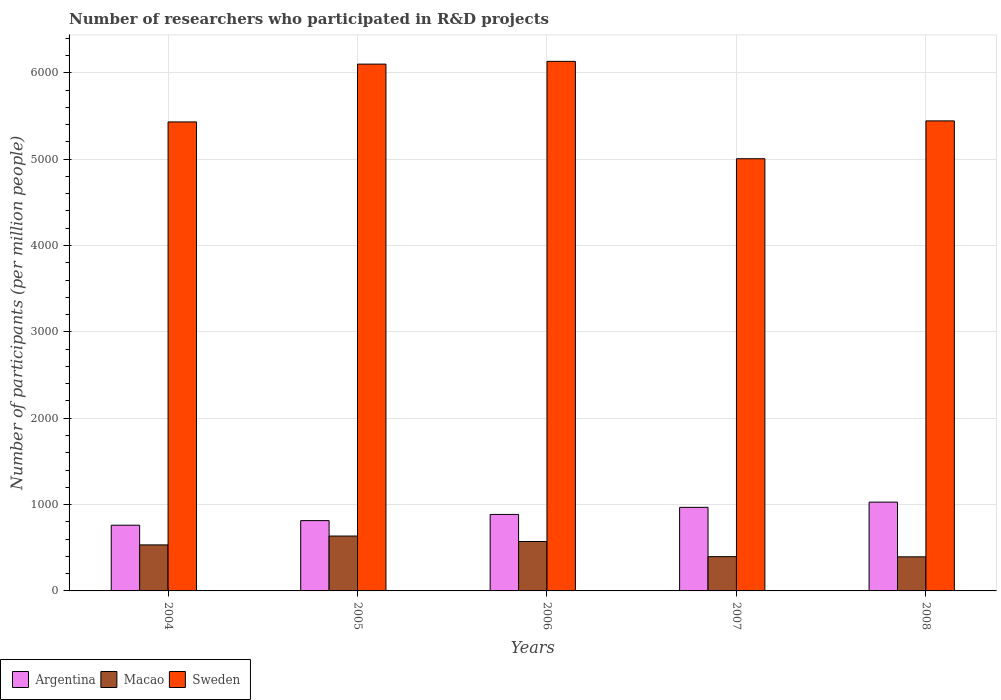How many different coloured bars are there?
Provide a short and direct response. 3. How many groups of bars are there?
Offer a terse response. 5. Are the number of bars per tick equal to the number of legend labels?
Your answer should be compact. Yes. How many bars are there on the 2nd tick from the left?
Provide a succinct answer. 3. How many bars are there on the 3rd tick from the right?
Provide a succinct answer. 3. What is the label of the 1st group of bars from the left?
Keep it short and to the point. 2004. What is the number of researchers who participated in R&D projects in Macao in 2005?
Your response must be concise. 635.48. Across all years, what is the maximum number of researchers who participated in R&D projects in Argentina?
Provide a succinct answer. 1028.26. Across all years, what is the minimum number of researchers who participated in R&D projects in Argentina?
Give a very brief answer. 760.96. In which year was the number of researchers who participated in R&D projects in Sweden maximum?
Ensure brevity in your answer.  2006. What is the total number of researchers who participated in R&D projects in Macao in the graph?
Your answer should be compact. 2532.44. What is the difference between the number of researchers who participated in R&D projects in Argentina in 2004 and that in 2007?
Offer a terse response. -206.79. What is the difference between the number of researchers who participated in R&D projects in Argentina in 2008 and the number of researchers who participated in R&D projects in Macao in 2006?
Your answer should be very brief. 455.85. What is the average number of researchers who participated in R&D projects in Sweden per year?
Your response must be concise. 5622.51. In the year 2005, what is the difference between the number of researchers who participated in R&D projects in Macao and number of researchers who participated in R&D projects in Argentina?
Keep it short and to the point. -178.61. What is the ratio of the number of researchers who participated in R&D projects in Macao in 2004 to that in 2006?
Your response must be concise. 0.93. Is the number of researchers who participated in R&D projects in Macao in 2005 less than that in 2008?
Your answer should be very brief. No. Is the difference between the number of researchers who participated in R&D projects in Macao in 2006 and 2007 greater than the difference between the number of researchers who participated in R&D projects in Argentina in 2006 and 2007?
Offer a very short reply. Yes. What is the difference between the highest and the second highest number of researchers who participated in R&D projects in Argentina?
Your answer should be very brief. 60.51. What is the difference between the highest and the lowest number of researchers who participated in R&D projects in Argentina?
Your response must be concise. 267.3. In how many years, is the number of researchers who participated in R&D projects in Argentina greater than the average number of researchers who participated in R&D projects in Argentina taken over all years?
Your answer should be very brief. 2. Is the sum of the number of researchers who participated in R&D projects in Argentina in 2004 and 2006 greater than the maximum number of researchers who participated in R&D projects in Sweden across all years?
Your answer should be compact. No. What does the 1st bar from the left in 2007 represents?
Offer a terse response. Argentina. What does the 1st bar from the right in 2006 represents?
Offer a terse response. Sweden. How many years are there in the graph?
Your response must be concise. 5. What is the difference between two consecutive major ticks on the Y-axis?
Provide a succinct answer. 1000. Are the values on the major ticks of Y-axis written in scientific E-notation?
Your response must be concise. No. Does the graph contain any zero values?
Provide a succinct answer. No. Does the graph contain grids?
Provide a short and direct response. Yes. How many legend labels are there?
Provide a succinct answer. 3. How are the legend labels stacked?
Give a very brief answer. Horizontal. What is the title of the graph?
Your response must be concise. Number of researchers who participated in R&D projects. What is the label or title of the Y-axis?
Offer a very short reply. Number of participants (per million people). What is the Number of participants (per million people) in Argentina in 2004?
Provide a succinct answer. 760.96. What is the Number of participants (per million people) of Macao in 2004?
Offer a terse response. 532.95. What is the Number of participants (per million people) of Sweden in 2004?
Keep it short and to the point. 5431.14. What is the Number of participants (per million people) in Argentina in 2005?
Keep it short and to the point. 814.09. What is the Number of participants (per million people) in Macao in 2005?
Your answer should be compact. 635.48. What is the Number of participants (per million people) in Sweden in 2005?
Offer a very short reply. 6100.67. What is the Number of participants (per million people) in Argentina in 2006?
Offer a terse response. 885.77. What is the Number of participants (per million people) in Macao in 2006?
Your answer should be very brief. 572.41. What is the Number of participants (per million people) of Sweden in 2006?
Give a very brief answer. 6132.66. What is the Number of participants (per million people) in Argentina in 2007?
Offer a very short reply. 967.75. What is the Number of participants (per million people) in Macao in 2007?
Your answer should be compact. 396.94. What is the Number of participants (per million people) of Sweden in 2007?
Your answer should be compact. 5004.96. What is the Number of participants (per million people) of Argentina in 2008?
Ensure brevity in your answer.  1028.26. What is the Number of participants (per million people) in Macao in 2008?
Offer a very short reply. 394.66. What is the Number of participants (per million people) of Sweden in 2008?
Give a very brief answer. 5443.12. Across all years, what is the maximum Number of participants (per million people) in Argentina?
Offer a very short reply. 1028.26. Across all years, what is the maximum Number of participants (per million people) of Macao?
Provide a short and direct response. 635.48. Across all years, what is the maximum Number of participants (per million people) in Sweden?
Your answer should be compact. 6132.66. Across all years, what is the minimum Number of participants (per million people) of Argentina?
Provide a short and direct response. 760.96. Across all years, what is the minimum Number of participants (per million people) of Macao?
Offer a terse response. 394.66. Across all years, what is the minimum Number of participants (per million people) of Sweden?
Give a very brief answer. 5004.96. What is the total Number of participants (per million people) of Argentina in the graph?
Give a very brief answer. 4456.83. What is the total Number of participants (per million people) of Macao in the graph?
Your answer should be compact. 2532.44. What is the total Number of participants (per million people) of Sweden in the graph?
Give a very brief answer. 2.81e+04. What is the difference between the Number of participants (per million people) of Argentina in 2004 and that in 2005?
Provide a succinct answer. -53.13. What is the difference between the Number of participants (per million people) of Macao in 2004 and that in 2005?
Ensure brevity in your answer.  -102.53. What is the difference between the Number of participants (per million people) of Sweden in 2004 and that in 2005?
Your response must be concise. -669.53. What is the difference between the Number of participants (per million people) in Argentina in 2004 and that in 2006?
Ensure brevity in your answer.  -124.81. What is the difference between the Number of participants (per million people) of Macao in 2004 and that in 2006?
Provide a short and direct response. -39.46. What is the difference between the Number of participants (per million people) in Sweden in 2004 and that in 2006?
Provide a short and direct response. -701.52. What is the difference between the Number of participants (per million people) of Argentina in 2004 and that in 2007?
Offer a very short reply. -206.79. What is the difference between the Number of participants (per million people) in Macao in 2004 and that in 2007?
Give a very brief answer. 136.01. What is the difference between the Number of participants (per million people) of Sweden in 2004 and that in 2007?
Give a very brief answer. 426.17. What is the difference between the Number of participants (per million people) of Argentina in 2004 and that in 2008?
Offer a terse response. -267.3. What is the difference between the Number of participants (per million people) of Macao in 2004 and that in 2008?
Keep it short and to the point. 138.29. What is the difference between the Number of participants (per million people) in Sweden in 2004 and that in 2008?
Ensure brevity in your answer.  -11.98. What is the difference between the Number of participants (per million people) in Argentina in 2005 and that in 2006?
Ensure brevity in your answer.  -71.68. What is the difference between the Number of participants (per million people) in Macao in 2005 and that in 2006?
Make the answer very short. 63.07. What is the difference between the Number of participants (per million people) of Sweden in 2005 and that in 2006?
Give a very brief answer. -31.99. What is the difference between the Number of participants (per million people) of Argentina in 2005 and that in 2007?
Provide a short and direct response. -153.66. What is the difference between the Number of participants (per million people) of Macao in 2005 and that in 2007?
Give a very brief answer. 238.54. What is the difference between the Number of participants (per million people) of Sweden in 2005 and that in 2007?
Provide a short and direct response. 1095.7. What is the difference between the Number of participants (per million people) of Argentina in 2005 and that in 2008?
Offer a very short reply. -214.17. What is the difference between the Number of participants (per million people) of Macao in 2005 and that in 2008?
Your answer should be compact. 240.82. What is the difference between the Number of participants (per million people) of Sweden in 2005 and that in 2008?
Provide a succinct answer. 657.55. What is the difference between the Number of participants (per million people) of Argentina in 2006 and that in 2007?
Ensure brevity in your answer.  -81.98. What is the difference between the Number of participants (per million people) of Macao in 2006 and that in 2007?
Ensure brevity in your answer.  175.47. What is the difference between the Number of participants (per million people) in Sweden in 2006 and that in 2007?
Keep it short and to the point. 1127.7. What is the difference between the Number of participants (per million people) of Argentina in 2006 and that in 2008?
Keep it short and to the point. -142.49. What is the difference between the Number of participants (per million people) in Macao in 2006 and that in 2008?
Your answer should be very brief. 177.75. What is the difference between the Number of participants (per million people) of Sweden in 2006 and that in 2008?
Provide a succinct answer. 689.54. What is the difference between the Number of participants (per million people) of Argentina in 2007 and that in 2008?
Your response must be concise. -60.51. What is the difference between the Number of participants (per million people) of Macao in 2007 and that in 2008?
Your answer should be compact. 2.28. What is the difference between the Number of participants (per million people) in Sweden in 2007 and that in 2008?
Give a very brief answer. -438.15. What is the difference between the Number of participants (per million people) in Argentina in 2004 and the Number of participants (per million people) in Macao in 2005?
Ensure brevity in your answer.  125.48. What is the difference between the Number of participants (per million people) in Argentina in 2004 and the Number of participants (per million people) in Sweden in 2005?
Your answer should be very brief. -5339.71. What is the difference between the Number of participants (per million people) in Macao in 2004 and the Number of participants (per million people) in Sweden in 2005?
Provide a succinct answer. -5567.71. What is the difference between the Number of participants (per million people) of Argentina in 2004 and the Number of participants (per million people) of Macao in 2006?
Give a very brief answer. 188.55. What is the difference between the Number of participants (per million people) of Argentina in 2004 and the Number of participants (per million people) of Sweden in 2006?
Your response must be concise. -5371.7. What is the difference between the Number of participants (per million people) in Macao in 2004 and the Number of participants (per million people) in Sweden in 2006?
Keep it short and to the point. -5599.71. What is the difference between the Number of participants (per million people) in Argentina in 2004 and the Number of participants (per million people) in Macao in 2007?
Offer a terse response. 364.02. What is the difference between the Number of participants (per million people) in Argentina in 2004 and the Number of participants (per million people) in Sweden in 2007?
Your answer should be compact. -4244. What is the difference between the Number of participants (per million people) of Macao in 2004 and the Number of participants (per million people) of Sweden in 2007?
Offer a very short reply. -4472.01. What is the difference between the Number of participants (per million people) in Argentina in 2004 and the Number of participants (per million people) in Macao in 2008?
Your answer should be compact. 366.3. What is the difference between the Number of participants (per million people) of Argentina in 2004 and the Number of participants (per million people) of Sweden in 2008?
Provide a succinct answer. -4682.16. What is the difference between the Number of participants (per million people) in Macao in 2004 and the Number of participants (per million people) in Sweden in 2008?
Offer a terse response. -4910.17. What is the difference between the Number of participants (per million people) of Argentina in 2005 and the Number of participants (per million people) of Macao in 2006?
Offer a terse response. 241.68. What is the difference between the Number of participants (per million people) of Argentina in 2005 and the Number of participants (per million people) of Sweden in 2006?
Offer a very short reply. -5318.57. What is the difference between the Number of participants (per million people) in Macao in 2005 and the Number of participants (per million people) in Sweden in 2006?
Your answer should be compact. -5497.18. What is the difference between the Number of participants (per million people) in Argentina in 2005 and the Number of participants (per million people) in Macao in 2007?
Your answer should be compact. 417.15. What is the difference between the Number of participants (per million people) in Argentina in 2005 and the Number of participants (per million people) in Sweden in 2007?
Ensure brevity in your answer.  -4190.87. What is the difference between the Number of participants (per million people) of Macao in 2005 and the Number of participants (per million people) of Sweden in 2007?
Your response must be concise. -4369.48. What is the difference between the Number of participants (per million people) in Argentina in 2005 and the Number of participants (per million people) in Macao in 2008?
Offer a very short reply. 419.43. What is the difference between the Number of participants (per million people) of Argentina in 2005 and the Number of participants (per million people) of Sweden in 2008?
Your answer should be compact. -4629.02. What is the difference between the Number of participants (per million people) in Macao in 2005 and the Number of participants (per million people) in Sweden in 2008?
Keep it short and to the point. -4807.63. What is the difference between the Number of participants (per million people) in Argentina in 2006 and the Number of participants (per million people) in Macao in 2007?
Your answer should be very brief. 488.83. What is the difference between the Number of participants (per million people) of Argentina in 2006 and the Number of participants (per million people) of Sweden in 2007?
Your response must be concise. -4119.19. What is the difference between the Number of participants (per million people) of Macao in 2006 and the Number of participants (per million people) of Sweden in 2007?
Provide a succinct answer. -4432.55. What is the difference between the Number of participants (per million people) of Argentina in 2006 and the Number of participants (per million people) of Macao in 2008?
Your answer should be compact. 491.11. What is the difference between the Number of participants (per million people) in Argentina in 2006 and the Number of participants (per million people) in Sweden in 2008?
Keep it short and to the point. -4557.34. What is the difference between the Number of participants (per million people) in Macao in 2006 and the Number of participants (per million people) in Sweden in 2008?
Give a very brief answer. -4870.71. What is the difference between the Number of participants (per million people) of Argentina in 2007 and the Number of participants (per million people) of Macao in 2008?
Your answer should be compact. 573.09. What is the difference between the Number of participants (per million people) in Argentina in 2007 and the Number of participants (per million people) in Sweden in 2008?
Give a very brief answer. -4475.36. What is the difference between the Number of participants (per million people) in Macao in 2007 and the Number of participants (per million people) in Sweden in 2008?
Ensure brevity in your answer.  -5046.18. What is the average Number of participants (per million people) of Argentina per year?
Your response must be concise. 891.37. What is the average Number of participants (per million people) of Macao per year?
Offer a terse response. 506.49. What is the average Number of participants (per million people) of Sweden per year?
Your response must be concise. 5622.51. In the year 2004, what is the difference between the Number of participants (per million people) of Argentina and Number of participants (per million people) of Macao?
Ensure brevity in your answer.  228.01. In the year 2004, what is the difference between the Number of participants (per million people) in Argentina and Number of participants (per million people) in Sweden?
Make the answer very short. -4670.18. In the year 2004, what is the difference between the Number of participants (per million people) of Macao and Number of participants (per million people) of Sweden?
Your answer should be compact. -4898.19. In the year 2005, what is the difference between the Number of participants (per million people) of Argentina and Number of participants (per million people) of Macao?
Your answer should be compact. 178.61. In the year 2005, what is the difference between the Number of participants (per million people) in Argentina and Number of participants (per million people) in Sweden?
Your answer should be very brief. -5286.57. In the year 2005, what is the difference between the Number of participants (per million people) of Macao and Number of participants (per million people) of Sweden?
Make the answer very short. -5465.18. In the year 2006, what is the difference between the Number of participants (per million people) of Argentina and Number of participants (per million people) of Macao?
Your response must be concise. 313.36. In the year 2006, what is the difference between the Number of participants (per million people) of Argentina and Number of participants (per million people) of Sweden?
Make the answer very short. -5246.89. In the year 2006, what is the difference between the Number of participants (per million people) in Macao and Number of participants (per million people) in Sweden?
Give a very brief answer. -5560.25. In the year 2007, what is the difference between the Number of participants (per million people) in Argentina and Number of participants (per million people) in Macao?
Provide a short and direct response. 570.81. In the year 2007, what is the difference between the Number of participants (per million people) in Argentina and Number of participants (per million people) in Sweden?
Give a very brief answer. -4037.21. In the year 2007, what is the difference between the Number of participants (per million people) in Macao and Number of participants (per million people) in Sweden?
Keep it short and to the point. -4608.02. In the year 2008, what is the difference between the Number of participants (per million people) of Argentina and Number of participants (per million people) of Macao?
Make the answer very short. 633.6. In the year 2008, what is the difference between the Number of participants (per million people) in Argentina and Number of participants (per million people) in Sweden?
Provide a succinct answer. -4414.86. In the year 2008, what is the difference between the Number of participants (per million people) in Macao and Number of participants (per million people) in Sweden?
Provide a succinct answer. -5048.46. What is the ratio of the Number of participants (per million people) in Argentina in 2004 to that in 2005?
Give a very brief answer. 0.93. What is the ratio of the Number of participants (per million people) in Macao in 2004 to that in 2005?
Offer a very short reply. 0.84. What is the ratio of the Number of participants (per million people) of Sweden in 2004 to that in 2005?
Give a very brief answer. 0.89. What is the ratio of the Number of participants (per million people) of Argentina in 2004 to that in 2006?
Make the answer very short. 0.86. What is the ratio of the Number of participants (per million people) in Macao in 2004 to that in 2006?
Provide a succinct answer. 0.93. What is the ratio of the Number of participants (per million people) of Sweden in 2004 to that in 2006?
Keep it short and to the point. 0.89. What is the ratio of the Number of participants (per million people) of Argentina in 2004 to that in 2007?
Your answer should be compact. 0.79. What is the ratio of the Number of participants (per million people) of Macao in 2004 to that in 2007?
Your answer should be very brief. 1.34. What is the ratio of the Number of participants (per million people) in Sweden in 2004 to that in 2007?
Provide a short and direct response. 1.09. What is the ratio of the Number of participants (per million people) of Argentina in 2004 to that in 2008?
Your response must be concise. 0.74. What is the ratio of the Number of participants (per million people) in Macao in 2004 to that in 2008?
Your answer should be very brief. 1.35. What is the ratio of the Number of participants (per million people) of Argentina in 2005 to that in 2006?
Provide a succinct answer. 0.92. What is the ratio of the Number of participants (per million people) in Macao in 2005 to that in 2006?
Your answer should be compact. 1.11. What is the ratio of the Number of participants (per million people) of Argentina in 2005 to that in 2007?
Provide a short and direct response. 0.84. What is the ratio of the Number of participants (per million people) in Macao in 2005 to that in 2007?
Your response must be concise. 1.6. What is the ratio of the Number of participants (per million people) in Sweden in 2005 to that in 2007?
Provide a succinct answer. 1.22. What is the ratio of the Number of participants (per million people) of Argentina in 2005 to that in 2008?
Your response must be concise. 0.79. What is the ratio of the Number of participants (per million people) in Macao in 2005 to that in 2008?
Make the answer very short. 1.61. What is the ratio of the Number of participants (per million people) of Sweden in 2005 to that in 2008?
Provide a succinct answer. 1.12. What is the ratio of the Number of participants (per million people) of Argentina in 2006 to that in 2007?
Provide a short and direct response. 0.92. What is the ratio of the Number of participants (per million people) in Macao in 2006 to that in 2007?
Give a very brief answer. 1.44. What is the ratio of the Number of participants (per million people) in Sweden in 2006 to that in 2007?
Give a very brief answer. 1.23. What is the ratio of the Number of participants (per million people) of Argentina in 2006 to that in 2008?
Offer a very short reply. 0.86. What is the ratio of the Number of participants (per million people) in Macao in 2006 to that in 2008?
Make the answer very short. 1.45. What is the ratio of the Number of participants (per million people) in Sweden in 2006 to that in 2008?
Offer a terse response. 1.13. What is the ratio of the Number of participants (per million people) of Argentina in 2007 to that in 2008?
Make the answer very short. 0.94. What is the ratio of the Number of participants (per million people) in Sweden in 2007 to that in 2008?
Your answer should be very brief. 0.92. What is the difference between the highest and the second highest Number of participants (per million people) of Argentina?
Your answer should be compact. 60.51. What is the difference between the highest and the second highest Number of participants (per million people) in Macao?
Your response must be concise. 63.07. What is the difference between the highest and the second highest Number of participants (per million people) of Sweden?
Your response must be concise. 31.99. What is the difference between the highest and the lowest Number of participants (per million people) of Argentina?
Keep it short and to the point. 267.3. What is the difference between the highest and the lowest Number of participants (per million people) in Macao?
Provide a succinct answer. 240.82. What is the difference between the highest and the lowest Number of participants (per million people) in Sweden?
Offer a very short reply. 1127.7. 